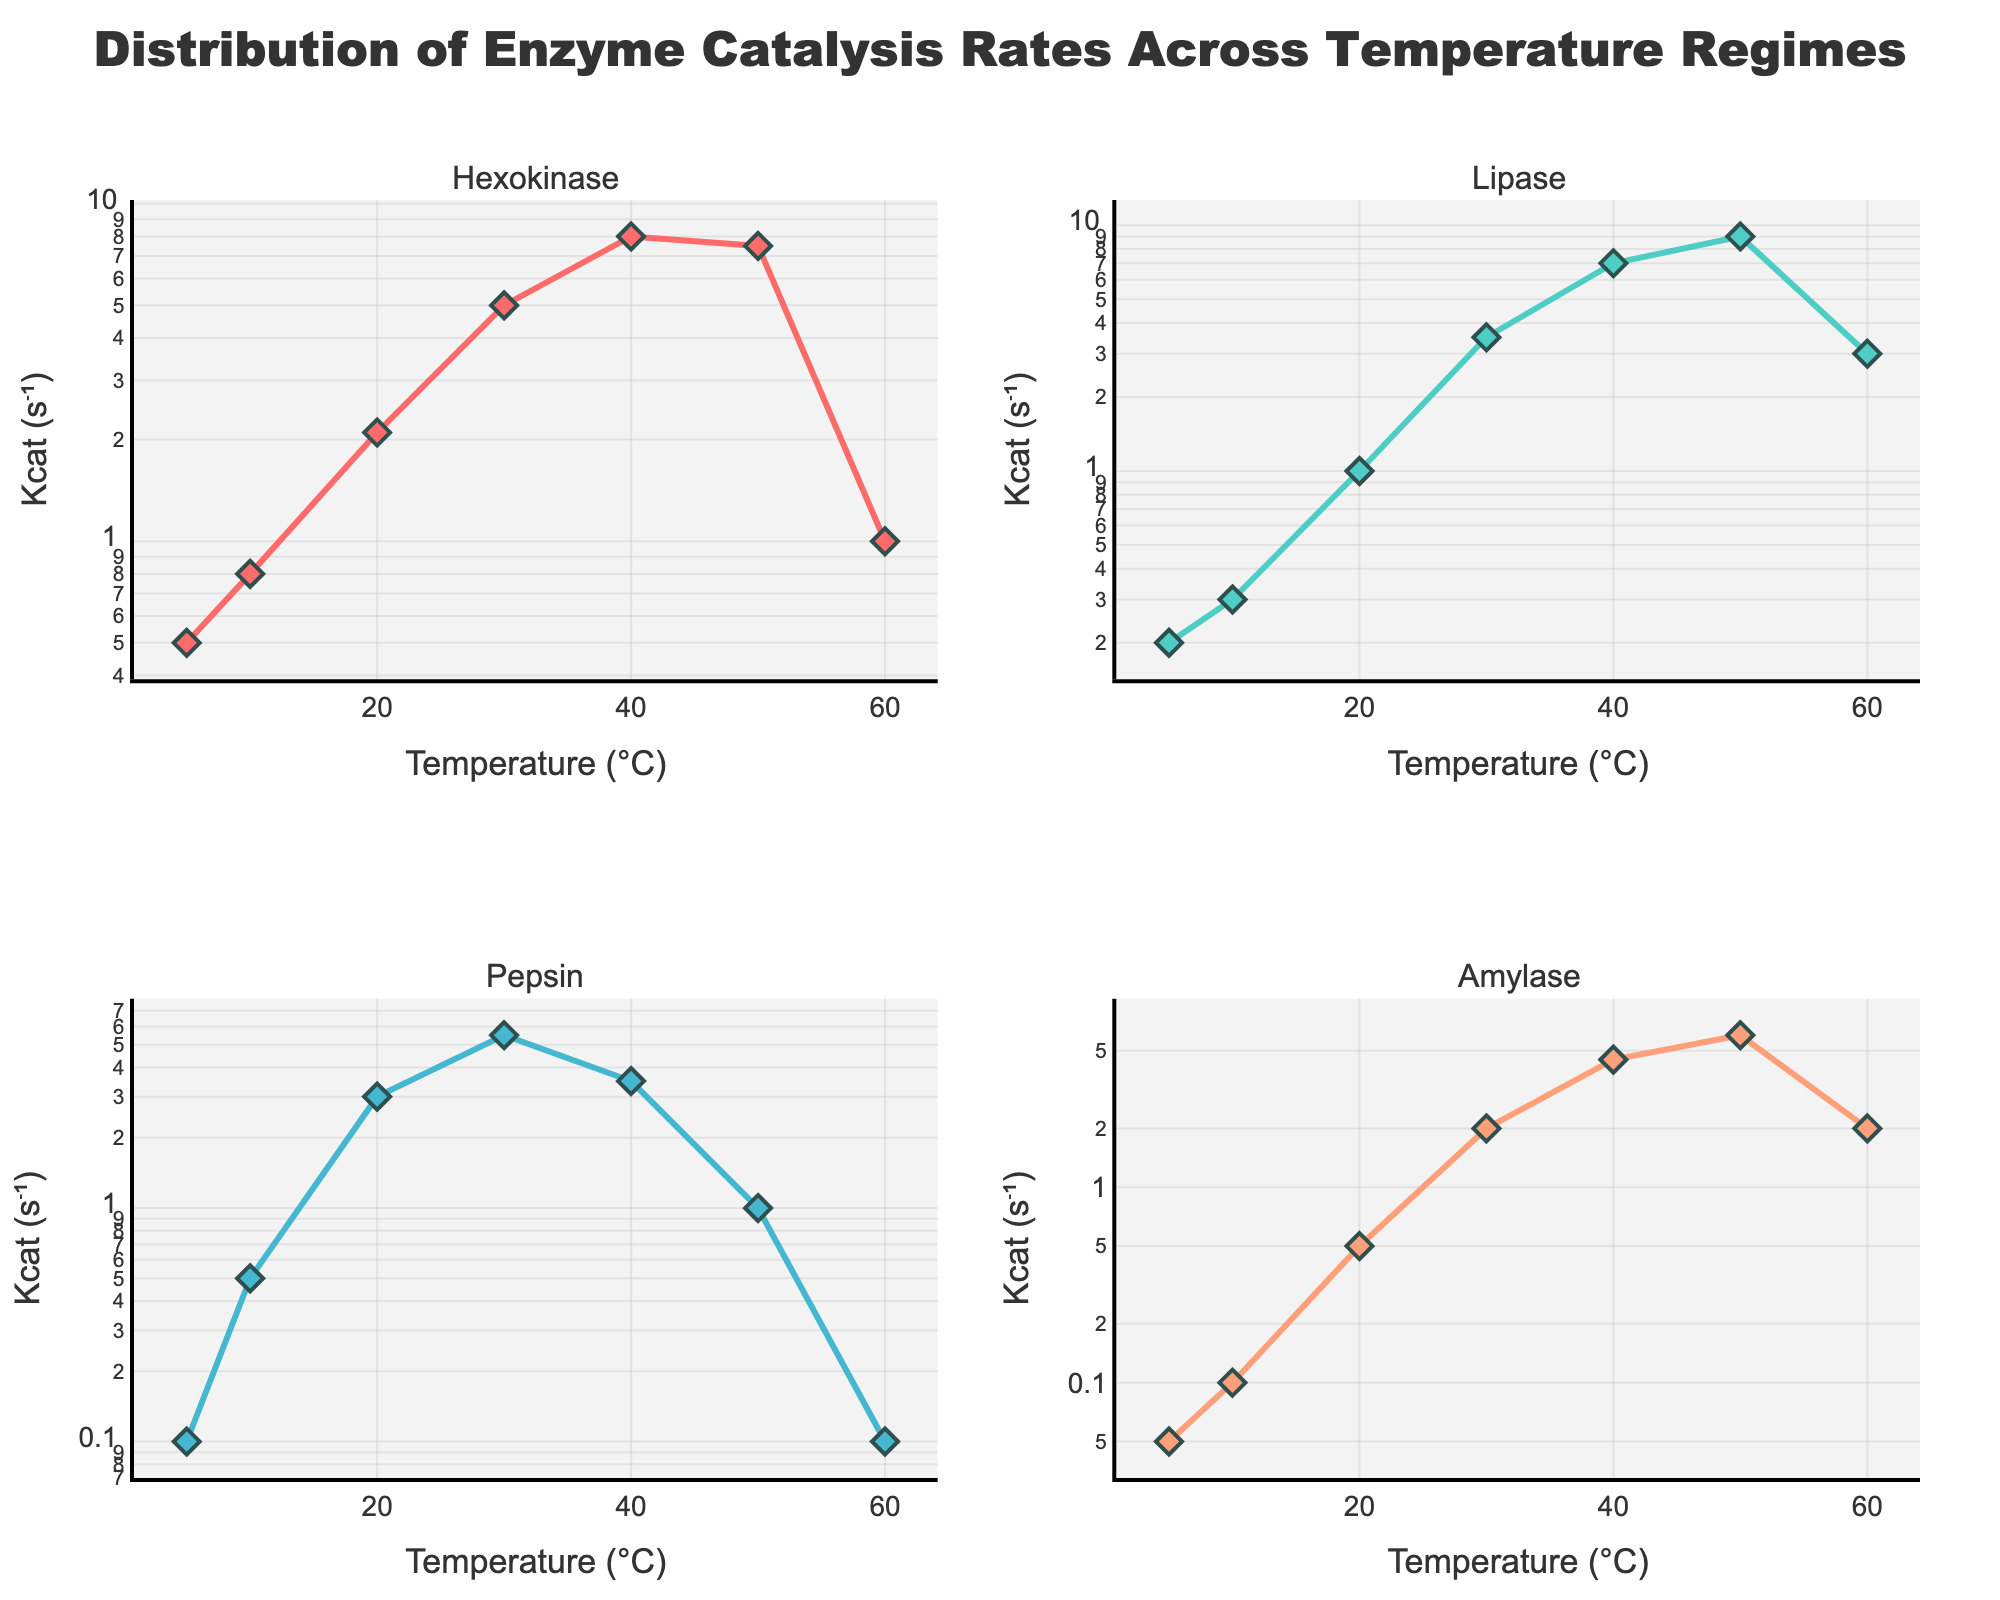What is the title of the figure? The title is prominently displayed at the top of the figure, describing the main subject of the data being visualized.
Answer: Distribution of Enzyme Catalysis Rates Across Temperature Regimes What are the x-axis labels in each subplot? Each subplot's x-axis is labeled with the same attribute, indicating what measurement is plotted along the horizontal axis.
Answer: Temperature (°C) Which enzyme reaches the highest catalytic rate (Kcat) and at what temperature? By looking at the peaks of each subplot's y-axis, which is plotted on a logarithmic scale, we can identify the maximum value and the corresponding temperature.
Answer: Lipase at 50°C In which subplot does the enzyme show a decrease in catalytic rate at the highest temperature recorded? Observing the trends in each subplot and identifying where the curve declines at the 60°C mark reveals which enzyme's rate decreases.
Answer: Hexokinase How does the catalytic rate of Amylase compare at 10°C and 50°C? By comparing the values on the y-axis of Amylase's subplot at 10°C and 50°C, we can see the difference in catalytic rates.
Answer: The catalytic rate at 50°C is 60 times higher than at 10°C Which enzyme has the smallest variation in catalytic rate across the temperature range? To determine this, we look at the range of Kcat values in each subplot and find the enzyme with the smallest range in values.
Answer: Amylase Between what temperature ranges does Pepsin show a peak in its catalytic rate? By identifying the highest point in Pepsin's subplot and the surrounding temperatures, we can define the range of this peak.
Answer: Between 20°C and 30°C If Kcat increases logarithmically with temperature, which enzyme follows this trend most consistently? Observing the shapes of the curves in each subplot, we can conclude which enzyme's data points form a smooth, increasing logarithmic trend.
Answer: Lipase How does the catalytic rate of Hexokinase differ between 5°C and 40°C? Comparing the data points on the y-axis of Hexokinase's subplot at these two temperatures gives the difference in catalytic rates.
Answer: The rate at 40°C is 16 times higher than at 5°C At which temperature does Amylase's catalytic rate start to decline? By examining the highest point in Amylase's subplot and seeing where the values begin to decrease, we can determine this temperature.
Answer: 50°C 